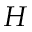Convert formula to latex. <formula><loc_0><loc_0><loc_500><loc_500>H</formula> 